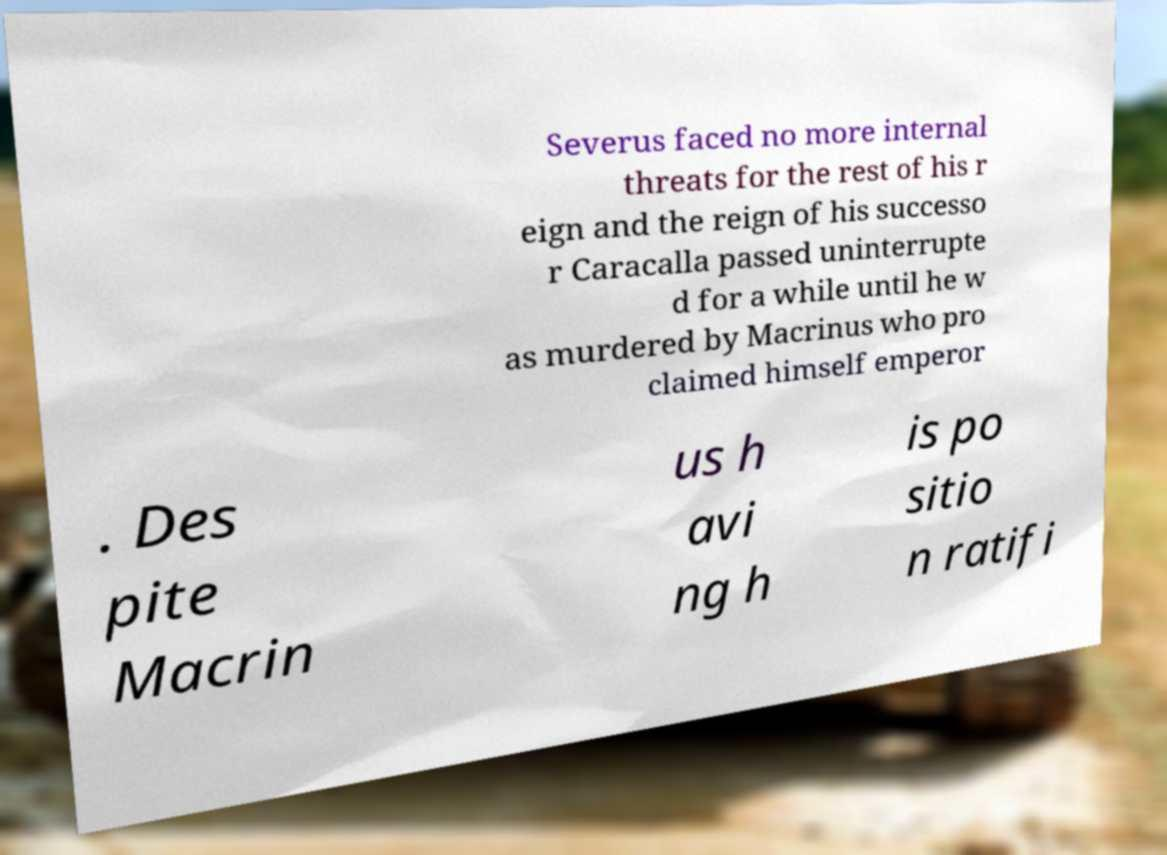Can you accurately transcribe the text from the provided image for me? Severus faced no more internal threats for the rest of his r eign and the reign of his successo r Caracalla passed uninterrupte d for a while until he w as murdered by Macrinus who pro claimed himself emperor . Des pite Macrin us h avi ng h is po sitio n ratifi 